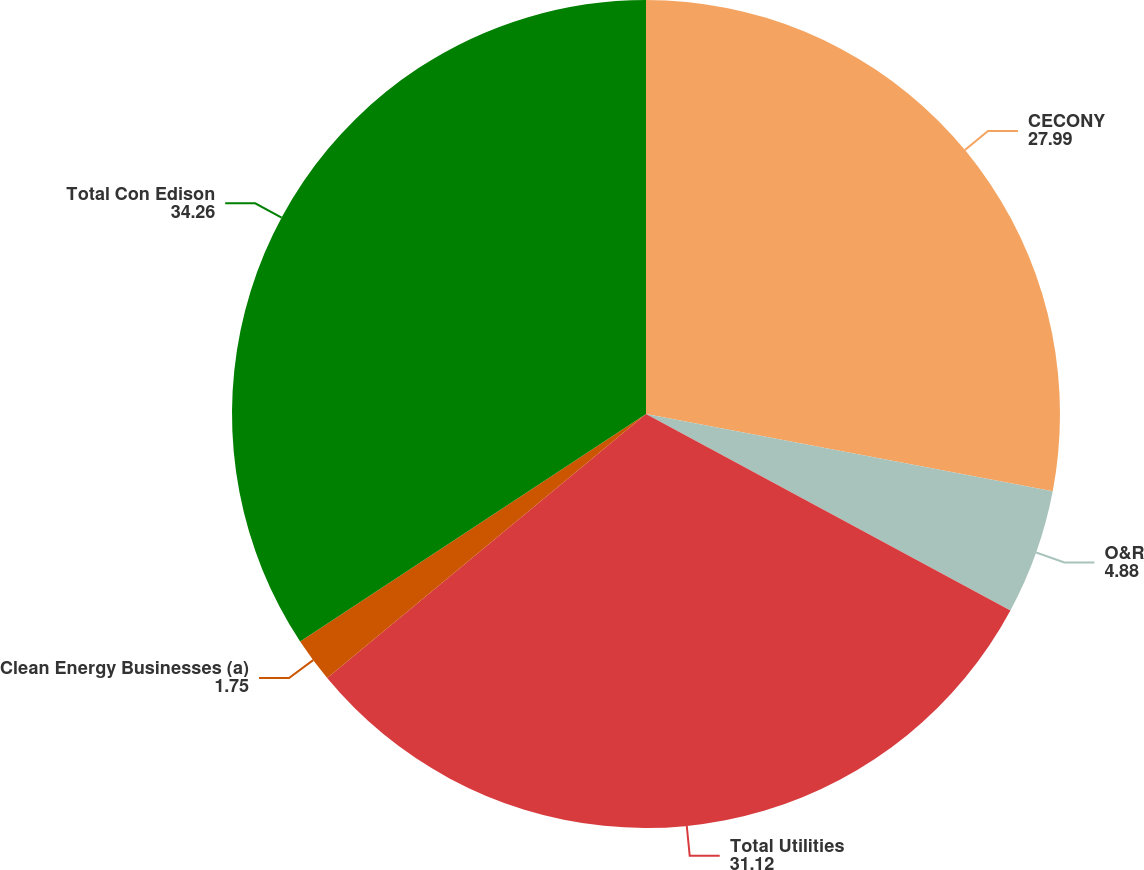Convert chart to OTSL. <chart><loc_0><loc_0><loc_500><loc_500><pie_chart><fcel>CECONY<fcel>O&R<fcel>Total Utilities<fcel>Clean Energy Businesses (a)<fcel>Total Con Edison<nl><fcel>27.99%<fcel>4.88%<fcel>31.12%<fcel>1.75%<fcel>34.26%<nl></chart> 